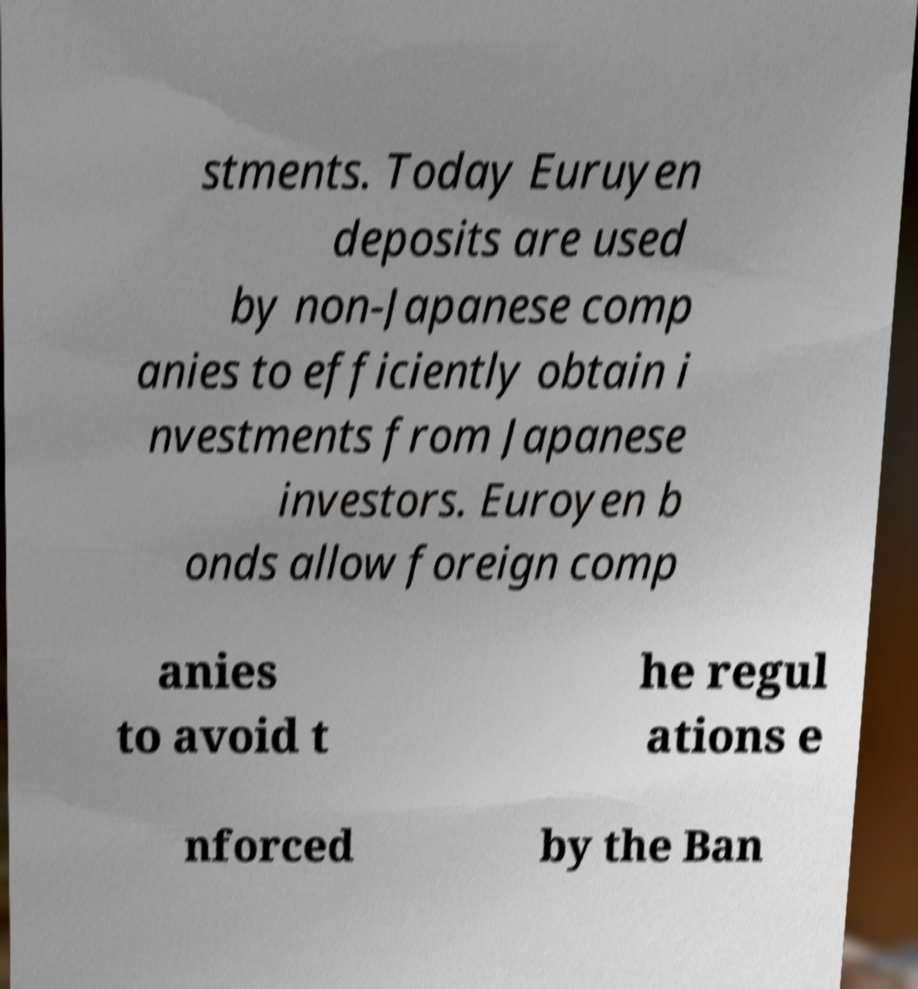Could you extract and type out the text from this image? stments. Today Euruyen deposits are used by non-Japanese comp anies to efficiently obtain i nvestments from Japanese investors. Euroyen b onds allow foreign comp anies to avoid t he regul ations e nforced by the Ban 